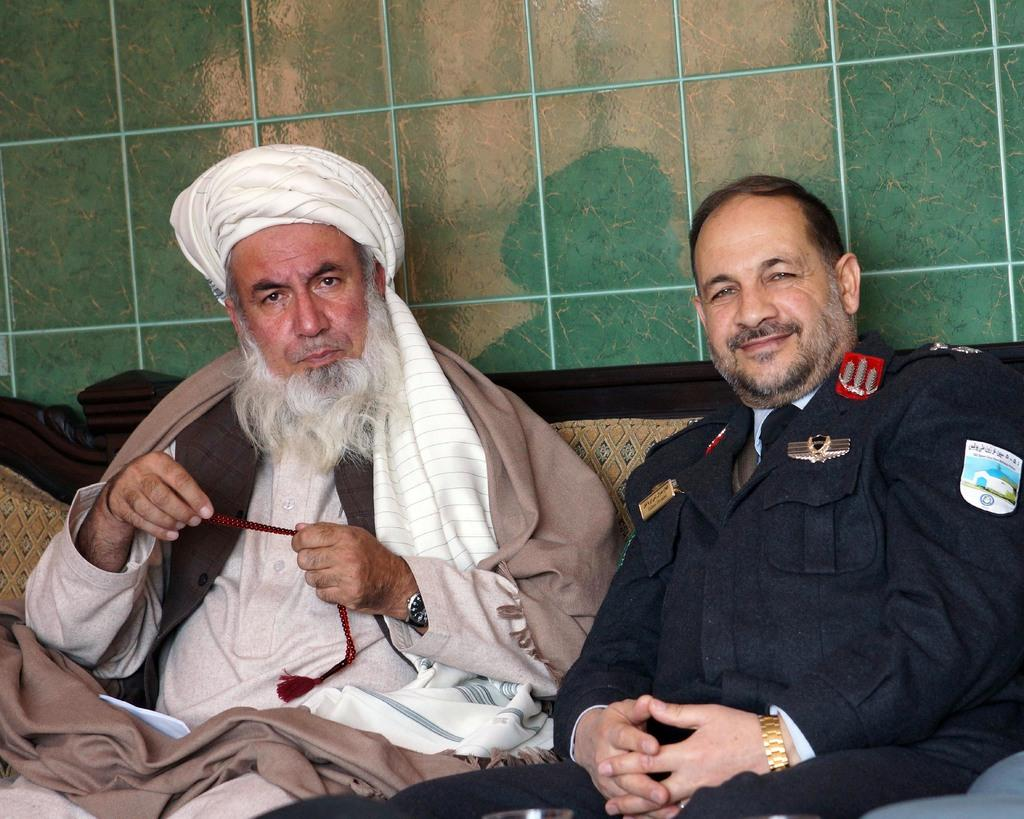How many people are in the image? There are two persons in the image. What are the persons doing in the image? The persons are sitting on a couch and smiling. What is behind the couch in the image? There is a wall behind the couch. What type of humor can be seen in the image? There is no specific type of humor present in the image; it simply shows two people sitting on a couch and smiling. 